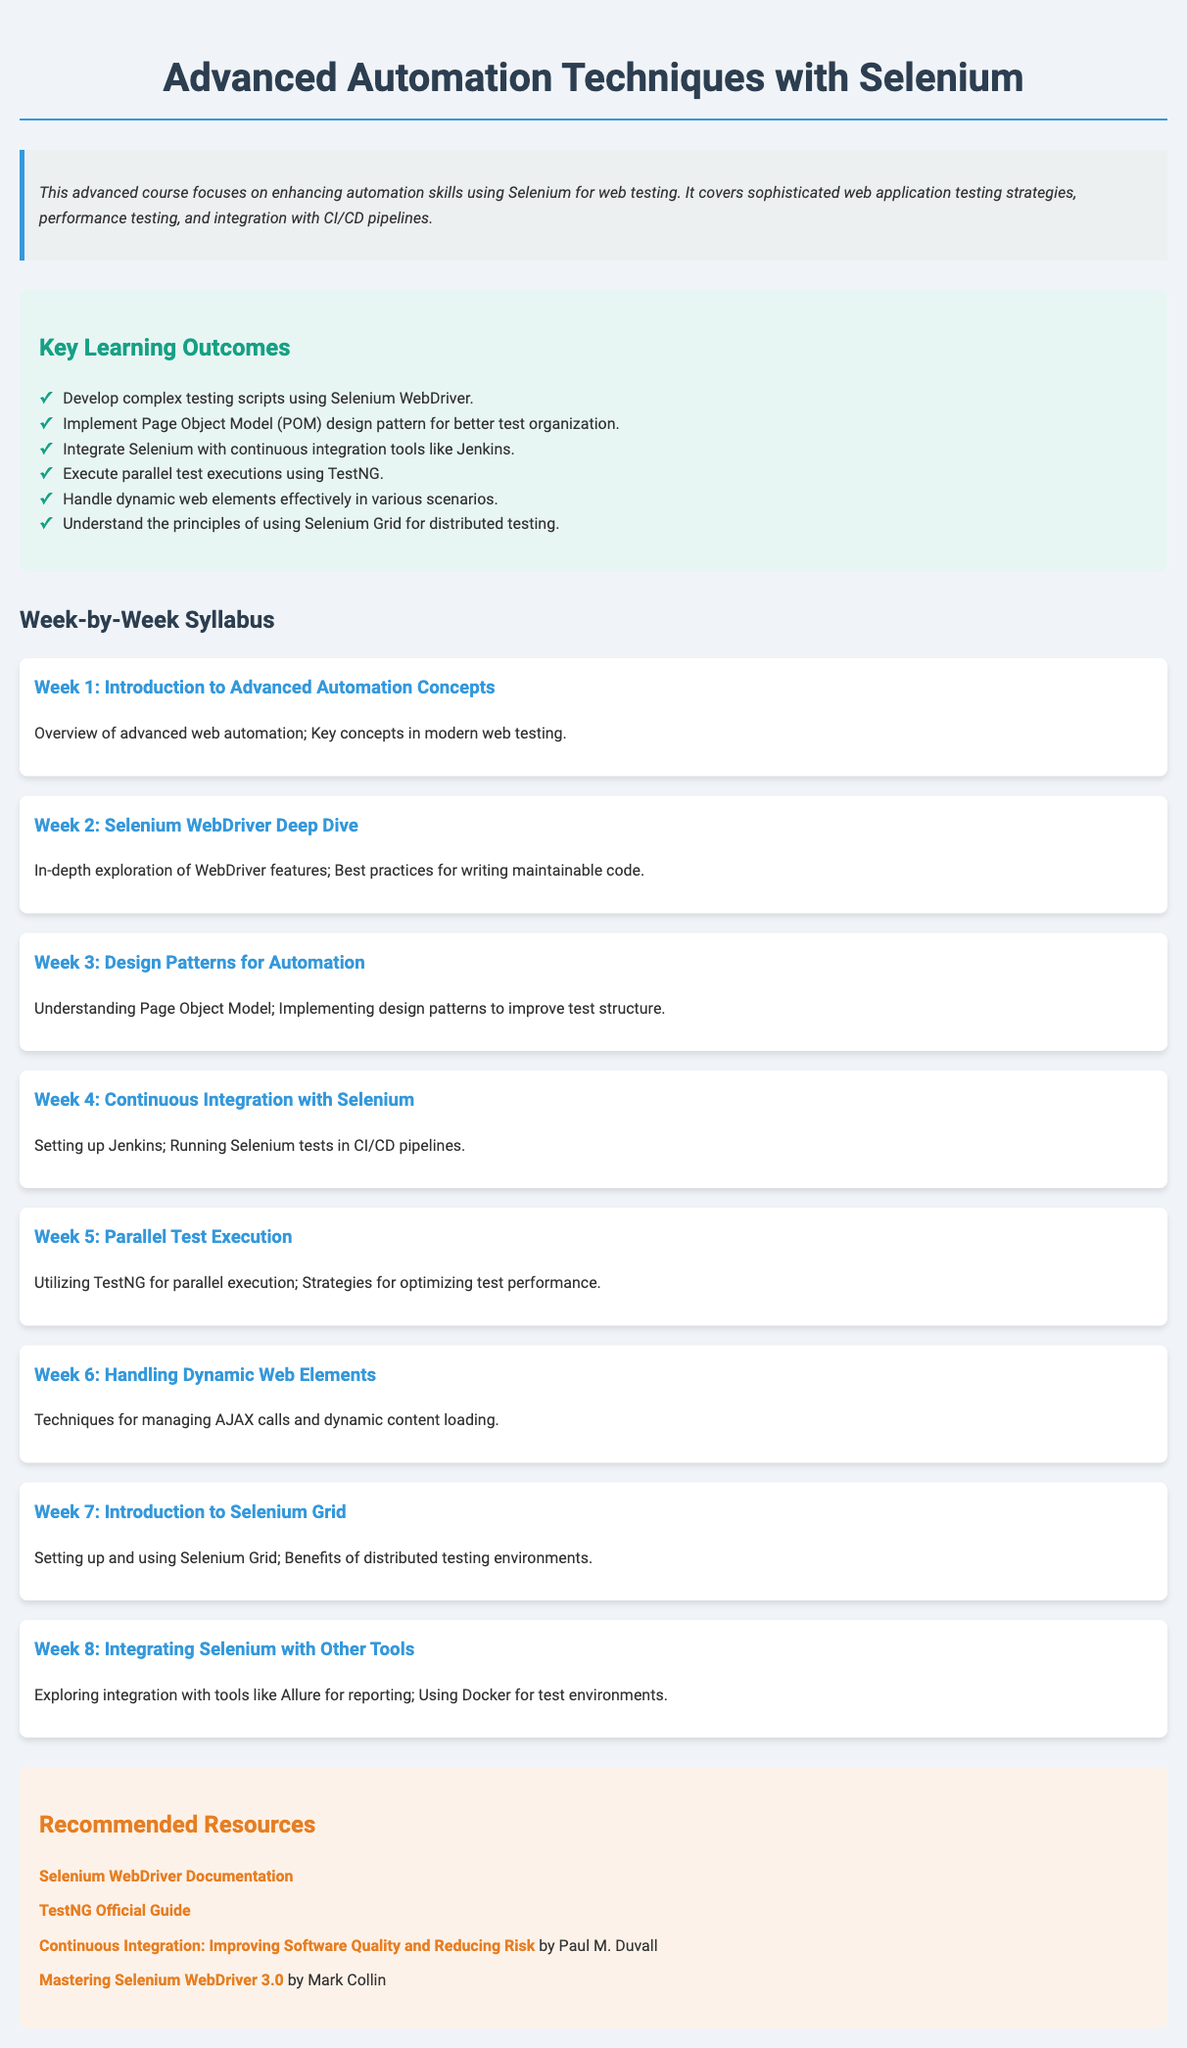what is the title of the course? The title of the course is mentioned at the top of the document as "Advanced Automation Techniques with Selenium."
Answer: Advanced Automation Techniques with Selenium how many weeks is the course syllabus? The syllabus is clearly structured week-by-week, and there are 8 weeks listed in the document.
Answer: 8 weeks which design pattern is discussed in the course? The document specifically mentions the Page Object Model (POM) as a design pattern covered in the course.
Answer: Page Object Model (POM) what is the primary tool used for continuous integration in this course? The document states that Jenkins is the tool used for integrating Selenium tests into CI/CD pipelines.
Answer: Jenkins name one recommended resource for Selenium WebDriver documentation. The document provides a link to the official Selenium WebDriver documentation as a recommended resource.
Answer: Selenium WebDriver Documentation what is the focus of Week 6 in the syllabus? Week 6 focuses on techniques for handling dynamic web elements, particularly those related to AJAX calls and dynamic content.
Answer: Handling Dynamic Web Elements which feature does TestNG provide for the course participants? TestNG is mentioned in the document as a tool that enables parallel test execution for improved performance.
Answer: Parallel test execution what is the background color for the resources section? The resources section in the document has a background color of #fdf2e9.
Answer: #fdf2e9 